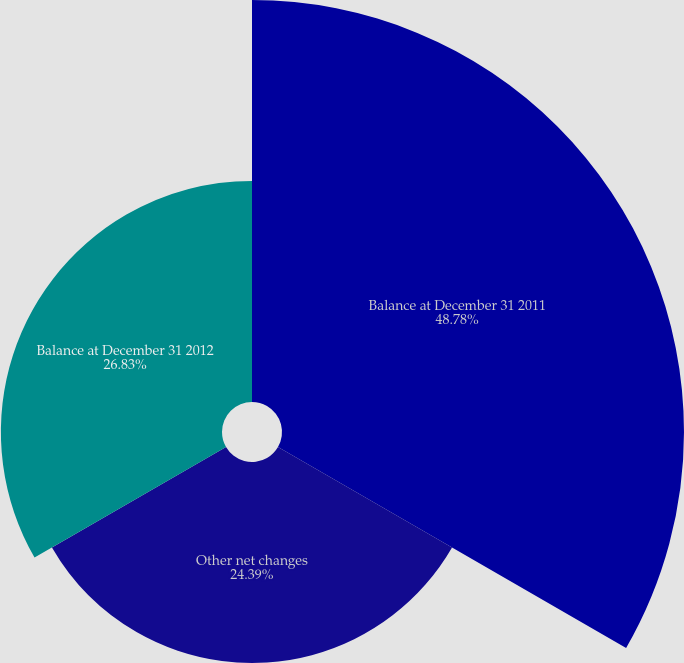Convert chart to OTSL. <chart><loc_0><loc_0><loc_500><loc_500><pie_chart><fcel>Balance at December 31 2011<fcel>Other net changes<fcel>Balance at December 31 2012<nl><fcel>48.78%<fcel>24.39%<fcel>26.83%<nl></chart> 